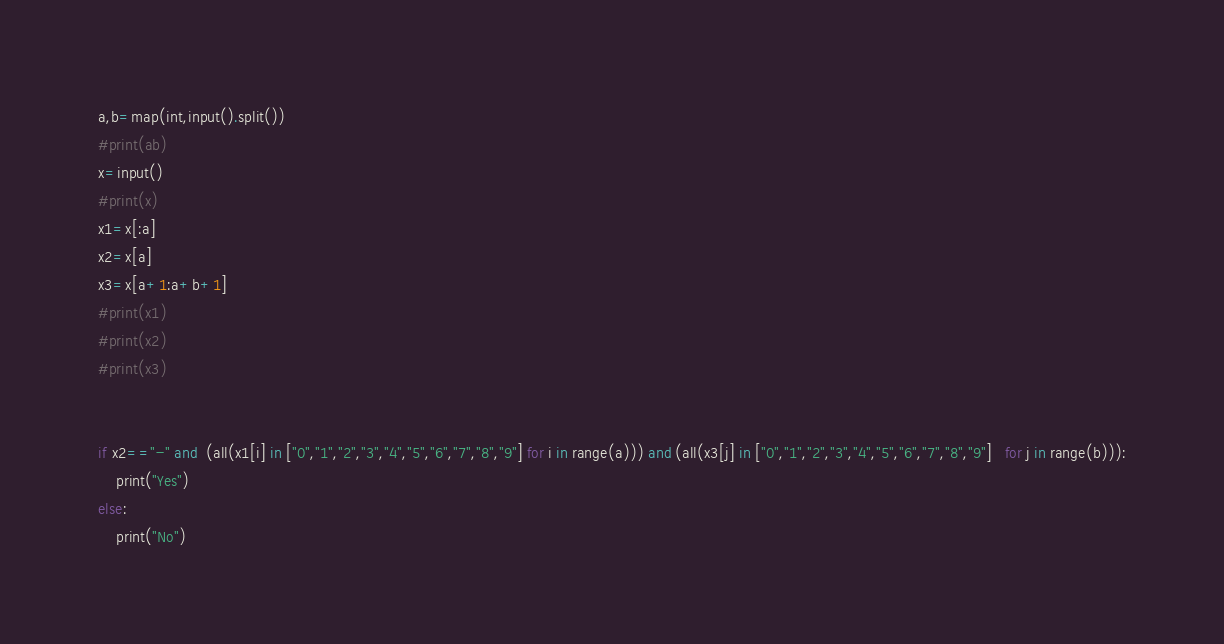<code> <loc_0><loc_0><loc_500><loc_500><_Python_>a,b=map(int,input().split())
#print(ab)
x=input()
#print(x)
x1=x[:a]
x2=x[a]
x3=x[a+1:a+b+1]
#print(x1)
#print(x2)
#print(x3)


if x2=="-" and  (all(x1[i] in ["0","1","2","3","4","5","6","7","8","9"] for i in range(a))) and (all(x3[j] in ["0","1","2","3","4","5","6","7","8","9"]   for j in range(b))):
    print("Yes")
else:
    print("No")</code> 